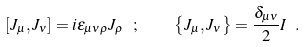Convert formula to latex. <formula><loc_0><loc_0><loc_500><loc_500>[ J _ { \mu } , J _ { \nu } ] = i \epsilon _ { \mu \nu \rho } J _ { \rho } \ ; \quad \left \{ J _ { \mu } , J _ { \nu } \right \} = \frac { \delta _ { \mu \nu } } { 2 } { I } \ .</formula> 